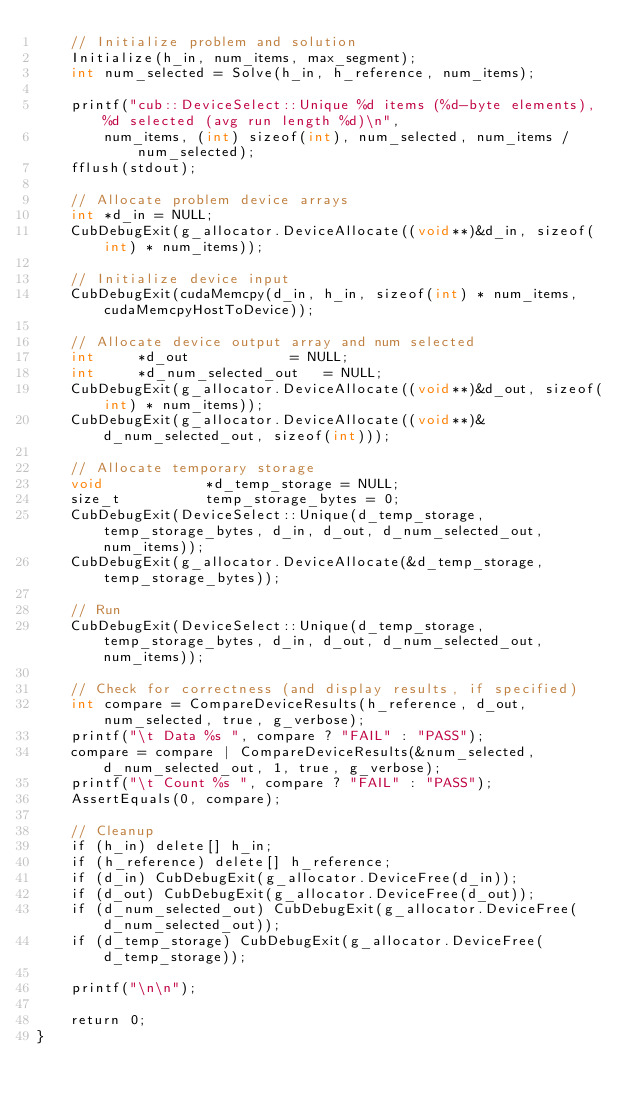Convert code to text. <code><loc_0><loc_0><loc_500><loc_500><_Cuda_>    // Initialize problem and solution
    Initialize(h_in, num_items, max_segment);
    int num_selected = Solve(h_in, h_reference, num_items);

    printf("cub::DeviceSelect::Unique %d items (%d-byte elements), %d selected (avg run length %d)\n",
        num_items, (int) sizeof(int), num_selected, num_items / num_selected);
    fflush(stdout);

    // Allocate problem device arrays
    int *d_in = NULL;
    CubDebugExit(g_allocator.DeviceAllocate((void**)&d_in, sizeof(int) * num_items));

    // Initialize device input
    CubDebugExit(cudaMemcpy(d_in, h_in, sizeof(int) * num_items, cudaMemcpyHostToDevice));

    // Allocate device output array and num selected
    int     *d_out            = NULL;
    int     *d_num_selected_out   = NULL;
    CubDebugExit(g_allocator.DeviceAllocate((void**)&d_out, sizeof(int) * num_items));
    CubDebugExit(g_allocator.DeviceAllocate((void**)&d_num_selected_out, sizeof(int)));

    // Allocate temporary storage
    void            *d_temp_storage = NULL;
    size_t          temp_storage_bytes = 0;
    CubDebugExit(DeviceSelect::Unique(d_temp_storage, temp_storage_bytes, d_in, d_out, d_num_selected_out, num_items));
    CubDebugExit(g_allocator.DeviceAllocate(&d_temp_storage, temp_storage_bytes));

    // Run
    CubDebugExit(DeviceSelect::Unique(d_temp_storage, temp_storage_bytes, d_in, d_out, d_num_selected_out, num_items));

    // Check for correctness (and display results, if specified)
    int compare = CompareDeviceResults(h_reference, d_out, num_selected, true, g_verbose);
    printf("\t Data %s ", compare ? "FAIL" : "PASS");
    compare = compare | CompareDeviceResults(&num_selected, d_num_selected_out, 1, true, g_verbose);
    printf("\t Count %s ", compare ? "FAIL" : "PASS");
    AssertEquals(0, compare);

    // Cleanup
    if (h_in) delete[] h_in;
    if (h_reference) delete[] h_reference;
    if (d_in) CubDebugExit(g_allocator.DeviceFree(d_in));
    if (d_out) CubDebugExit(g_allocator.DeviceFree(d_out));
    if (d_num_selected_out) CubDebugExit(g_allocator.DeviceFree(d_num_selected_out));
    if (d_temp_storage) CubDebugExit(g_allocator.DeviceFree(d_temp_storage));

    printf("\n\n");

    return 0;
}



</code> 